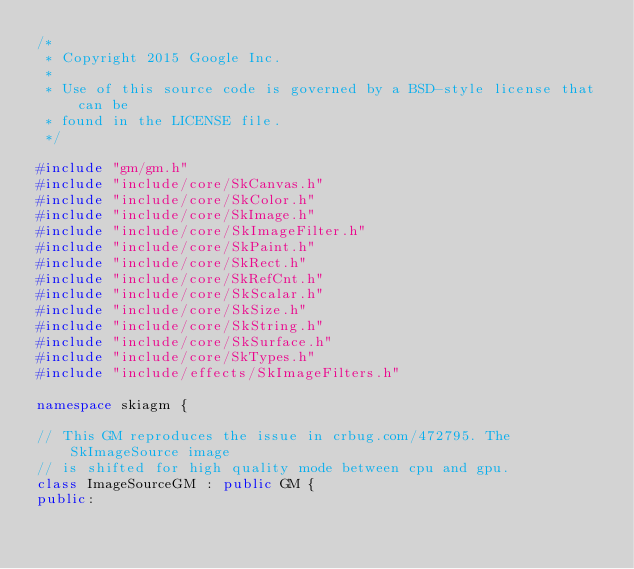<code> <loc_0><loc_0><loc_500><loc_500><_C++_>/*
 * Copyright 2015 Google Inc.
 *
 * Use of this source code is governed by a BSD-style license that can be
 * found in the LICENSE file.
 */

#include "gm/gm.h"
#include "include/core/SkCanvas.h"
#include "include/core/SkColor.h"
#include "include/core/SkImage.h"
#include "include/core/SkImageFilter.h"
#include "include/core/SkPaint.h"
#include "include/core/SkRect.h"
#include "include/core/SkRefCnt.h"
#include "include/core/SkScalar.h"
#include "include/core/SkSize.h"
#include "include/core/SkString.h"
#include "include/core/SkSurface.h"
#include "include/core/SkTypes.h"
#include "include/effects/SkImageFilters.h"

namespace skiagm {

// This GM reproduces the issue in crbug.com/472795. The SkImageSource image
// is shifted for high quality mode between cpu and gpu.
class ImageSourceGM : public GM {
public:</code> 